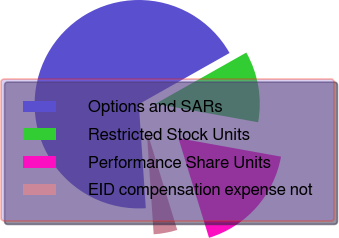Convert chart to OTSL. <chart><loc_0><loc_0><loc_500><loc_500><pie_chart><fcel>Options and SARs<fcel>Restricted Stock Units<fcel>Performance Share Units<fcel>EID compensation expense not<nl><fcel>67.89%<fcel>11.01%<fcel>17.43%<fcel>3.67%<nl></chart> 